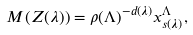Convert formula to latex. <formula><loc_0><loc_0><loc_500><loc_500>M ( Z ( \lambda ) ) = \rho ( \Lambda ) ^ { - d ( \lambda ) } x ^ { \Lambda } _ { s ( \lambda ) } ,</formula> 